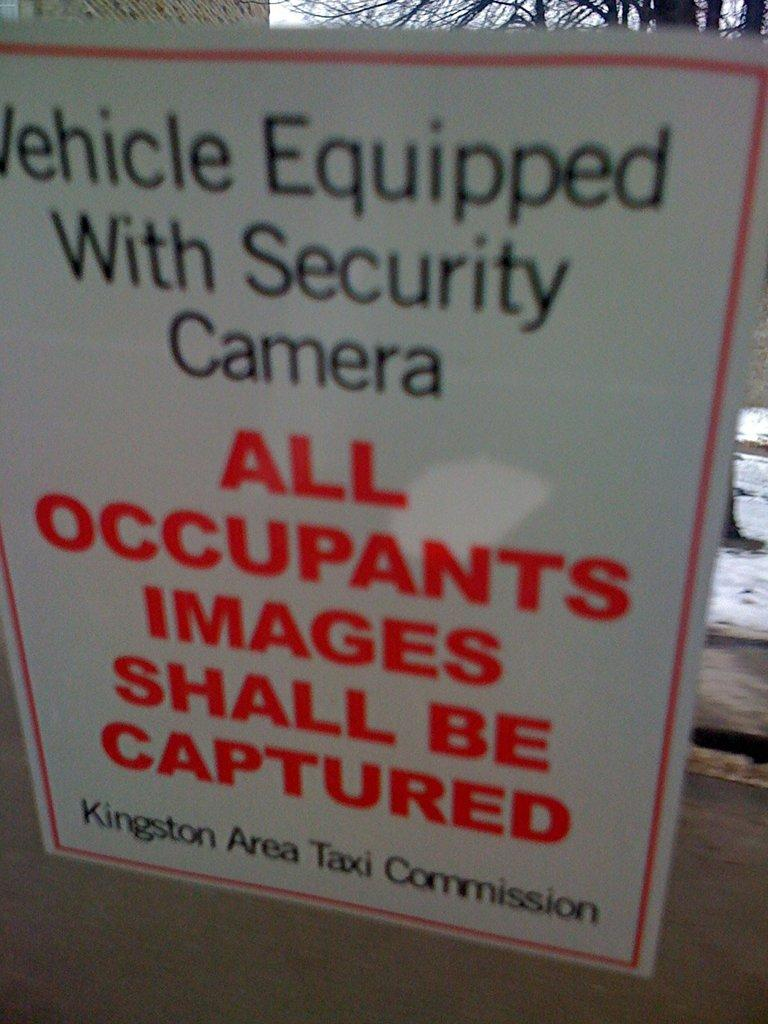Provide a one-sentence caption for the provided image. a warning sign that all images will be captured. 